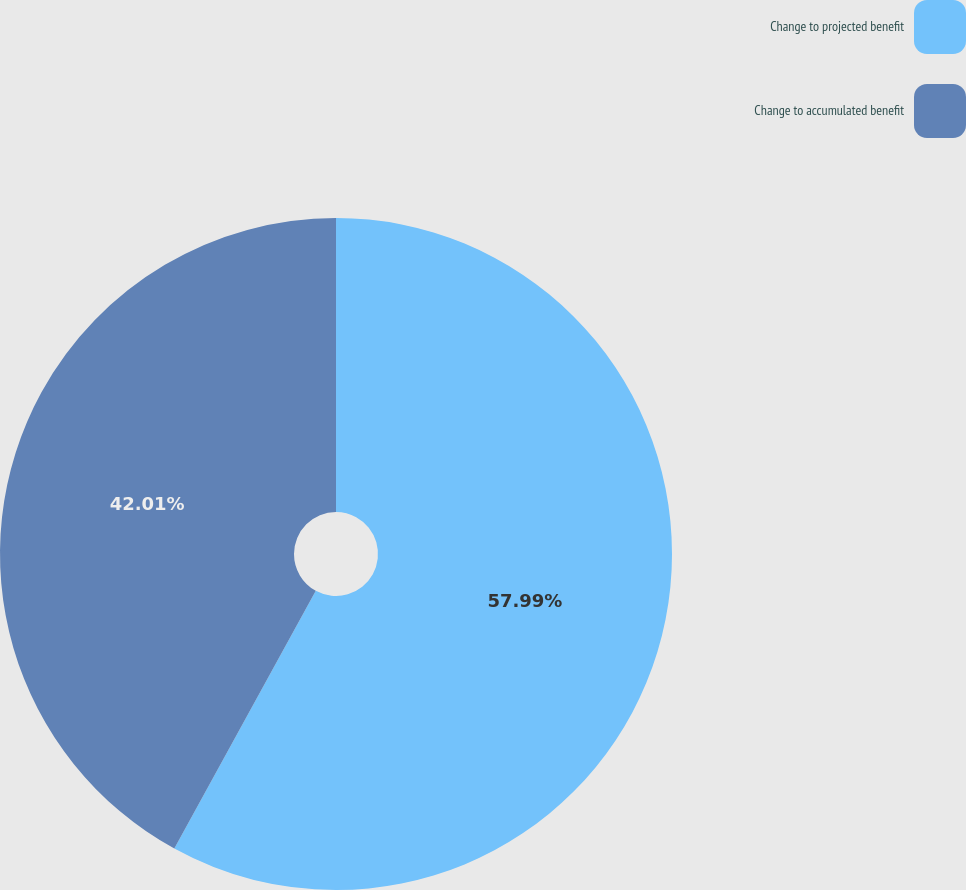Convert chart to OTSL. <chart><loc_0><loc_0><loc_500><loc_500><pie_chart><fcel>Change to projected benefit<fcel>Change to accumulated benefit<nl><fcel>57.99%<fcel>42.01%<nl></chart> 